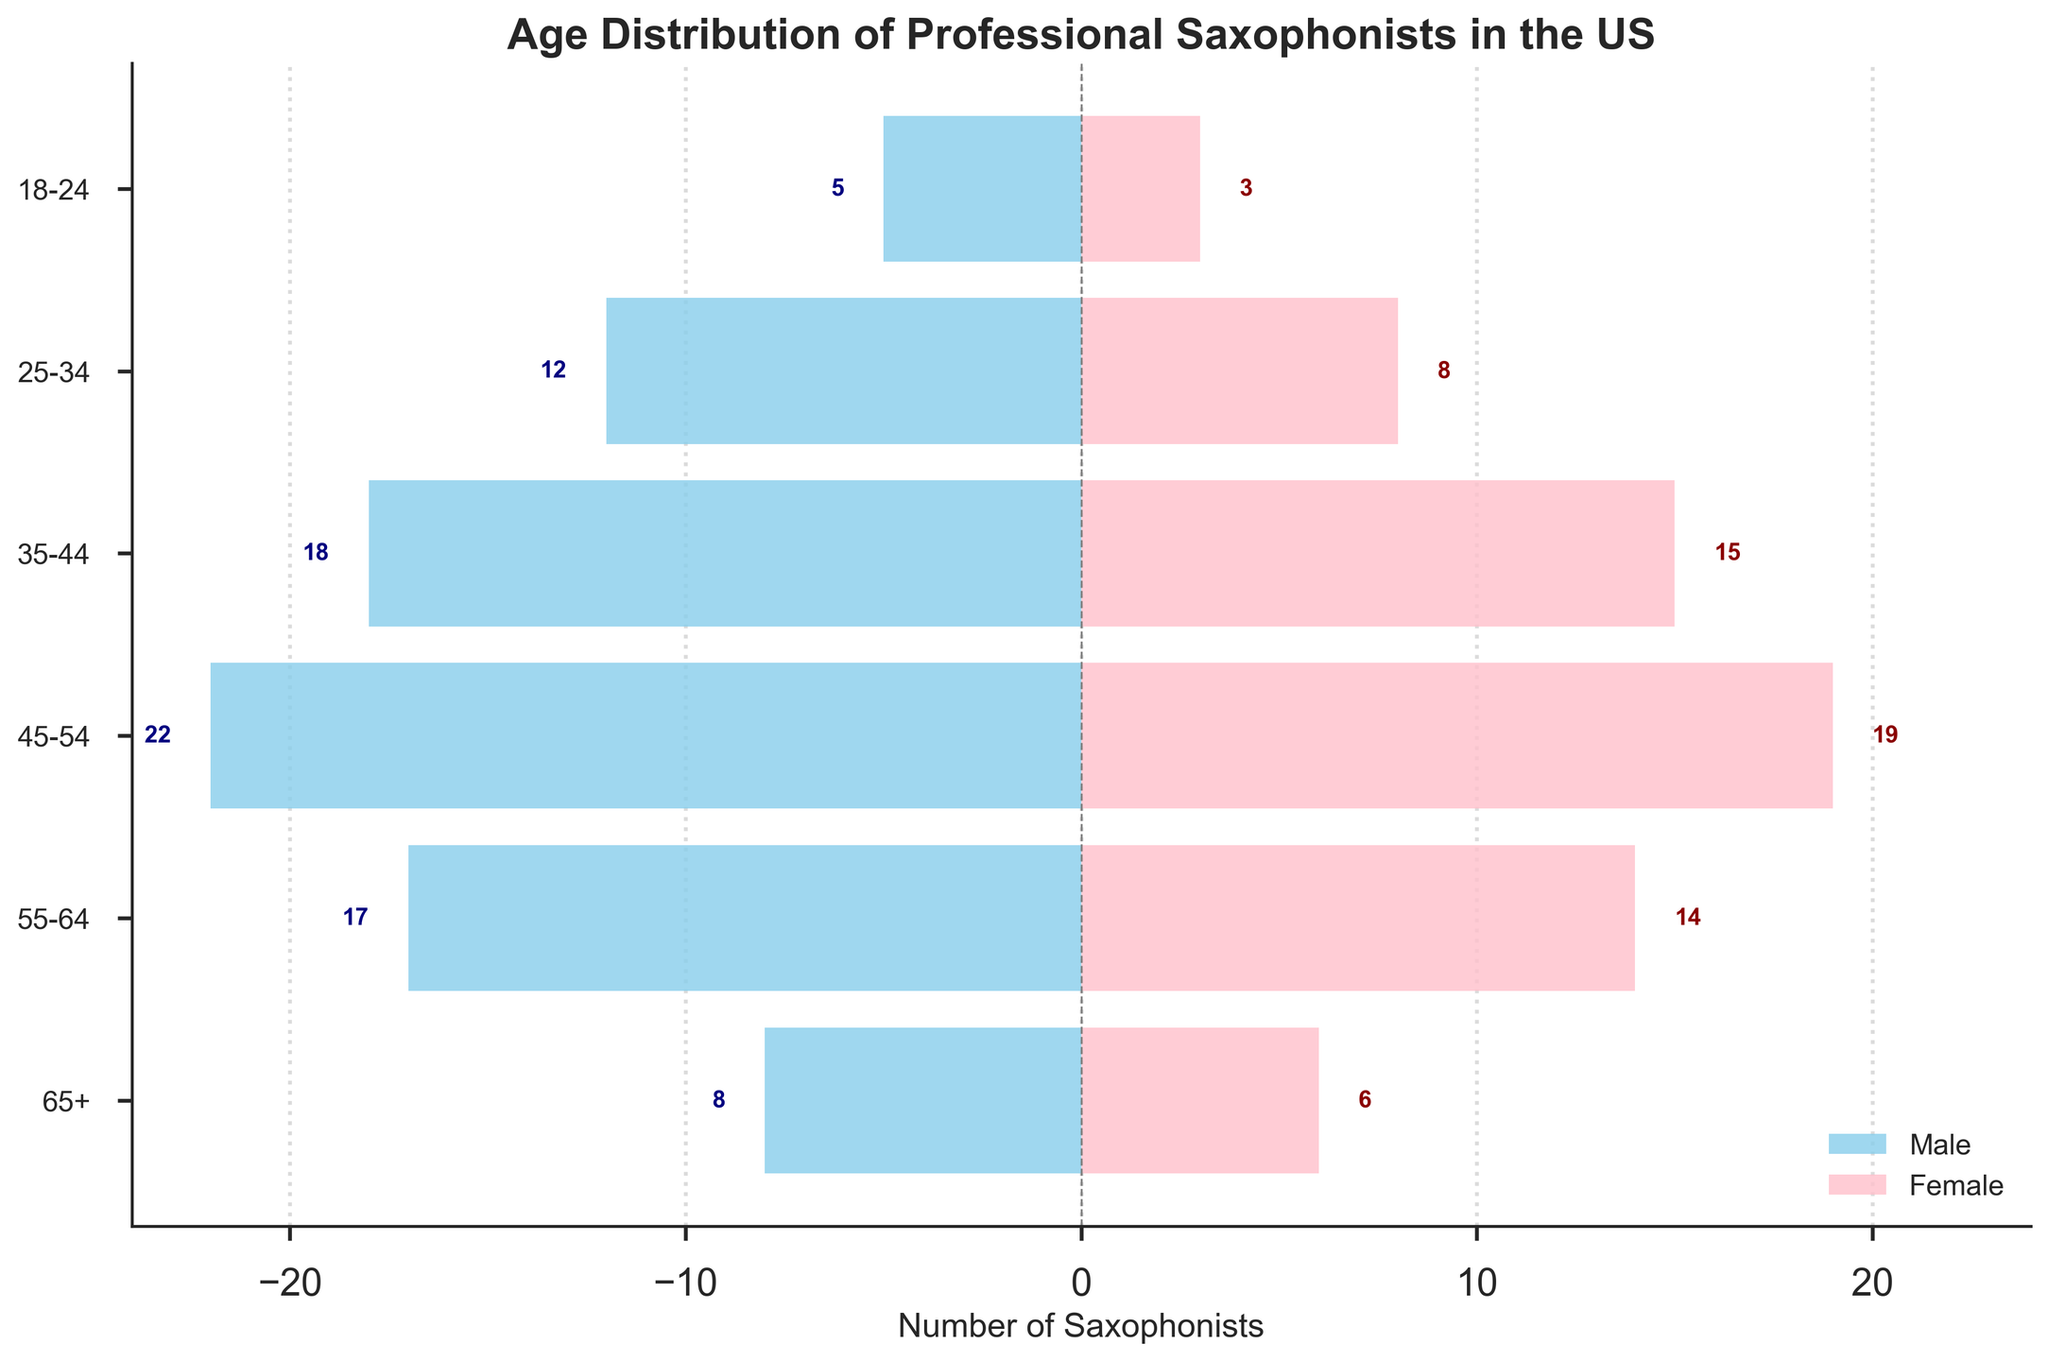What is the title of the chart? The title of the chart is prominently displayed at the top center of the figure.
Answer: Age Distribution of Professional Saxophonists in the US What age group has the highest number of male saxophonists? To find the age group with the highest number of male saxophonists, look for the longest light blue bar on the left side of the chart. The longest bar corresponds to the 45-54 age group.
Answer: 45-54 How many female saxophonists are in the 35-44 age group? Locate the 35-44 age group on the y-axis and see the length of the pink bar on the right side of the chart. The label next to the bar shows the number of female saxophonists.
Answer: 15 What is the total number of saxophonists (male and female) in the 55-64 age group? Add the number of male saxophonists and female saxophonists in the 55-64 age group by combining the values next to the bars for this group.
Answer: 31 Which gender has more saxophonists in the 25-34 age group, and by how much? Compare the lengths of the bars for the 25-34 age group on both sides of the chart. Subtract the shorter bar's value from the longer bar's value.
Answer: Males have 4 more saxophonists Which age group has the smallest number of saxophonists in total? Sum up the number of male and female saxophonists in each age group. The age group with the smallest total number is the one with the smallest sum.
Answer: 18-24 What is the combined number of male saxophonists in the 45-64 age range? Add the number of male saxophonists in the 45-54 and 55-64 age groups.
Answer: 39 How does the number of female saxophonists in the 65+ age group compare to the number of male saxophonists in the same age group? Compare the pink and light blue bars for the 65+ age group directly.
Answer: Males exceed by 2 What is the age group with the maximum gender disparity, and what is that disparity? Calculate the absolute difference between the number of male and female saxophonists for each age group. The age group with the largest disparity is 45-54, with a difference of 3.
Answer: 45-54, difference of 3 